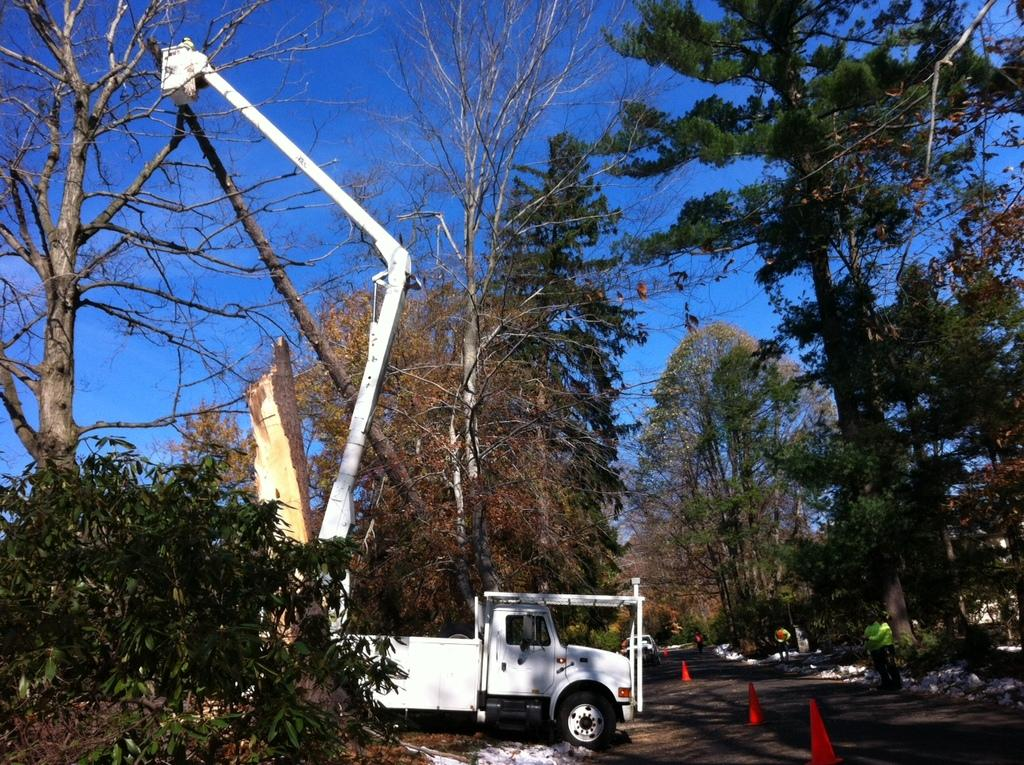What type of bird is present in the image? There is a white color crane in the image. What type of vegetation can be seen in the image? There are green trees in the image. What color is the sky in the image? The sky is blue in the image. How many pigs are visible in the image? There are no pigs present in the image. What type of view can be seen from the crane's perspective in the image? The image does not provide a perspective from the crane, so it is not possible to determine the view from its perspective. 